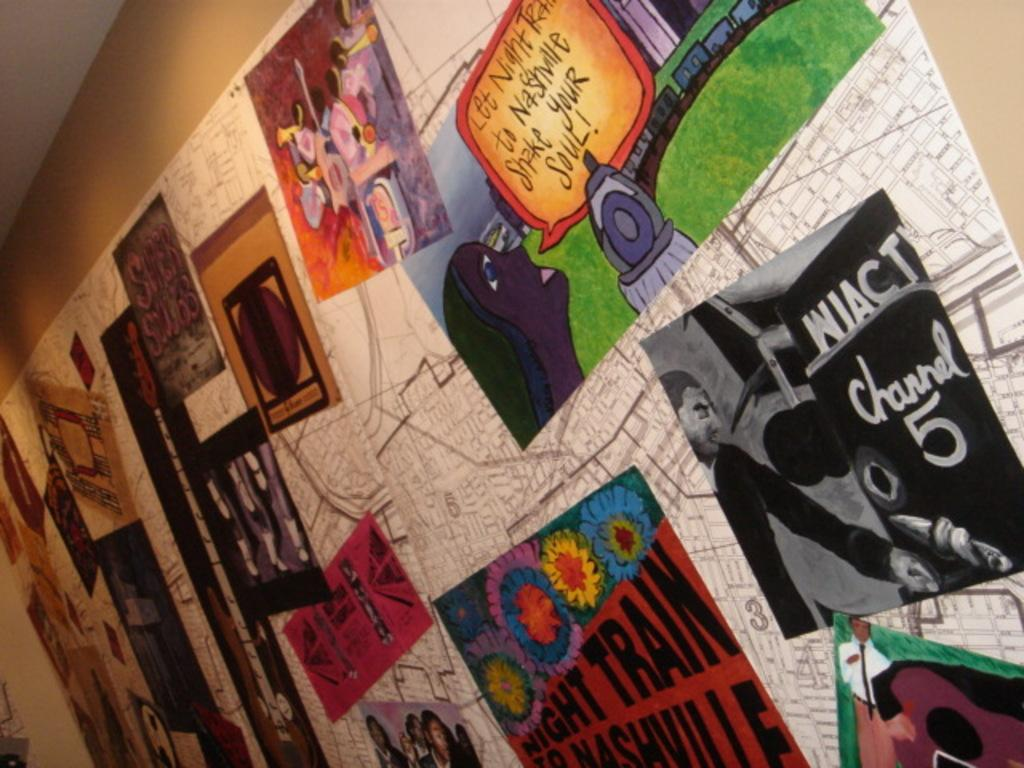<image>
Create a compact narrative representing the image presented. A wall has a map on it and other colorful posters that say Night Train. 